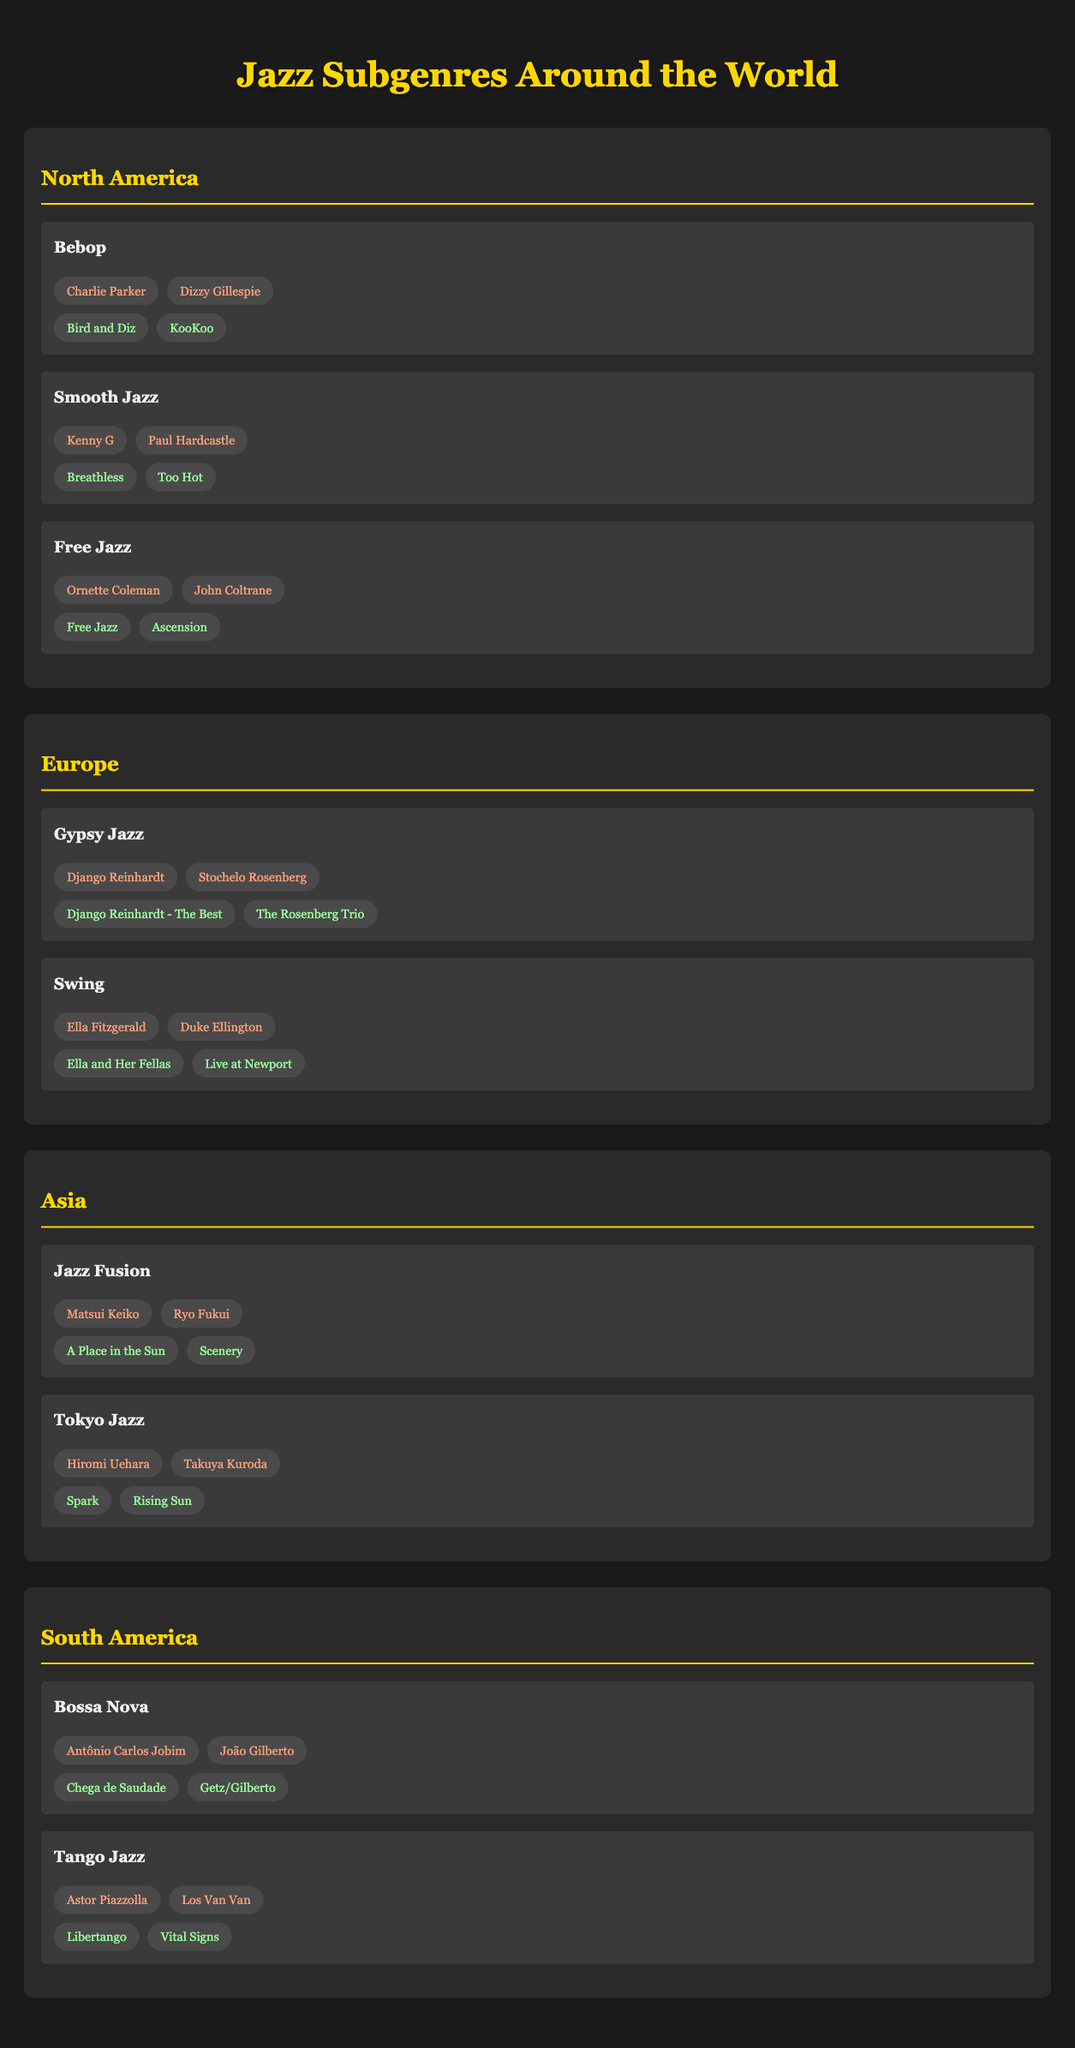What are the notable albums for the Bebop subgenre? The table specifies the notable albums under the Bebop subgenre listed in North America. They are "Bird and Diz" and "KooKoo."
Answer: Bird and Diz, KooKoo Which region is associated with Gypsy Jazz? According to the table, Gypsy Jazz is included in the Europe section, indicating that it is primarily associated with that region.
Answer: Europe Are there any South American subgenres featuring João Gilberto? The table shows that Bossa Nova, which features João Gilberto, is listed under the South America section. Therefore, the answer is yes.
Answer: Yes How many notable albums are listed for the Tango Jazz subgenre? The table lists two notable albums for Tango Jazz: "Libertango" and "Vital Signs." Therefore, the count is two.
Answer: 2 Which artists are known for Smooth Jazz? In the North America section, the artists listed under Smooth Jazz are Kenny G and Paul Hardcastle.
Answer: Kenny G, Paul Hardcastle Which subgenres have notable albums related to John Coltrane? John Coltrane is associated with the Free Jazz subgenre in North America, and the notable albums listed for it are "Free Jazz" and "Ascension."
Answer: Free Jazz Is Ella Fitzgerald an artist featured in the Tokyo Jazz subgenre? Checking the artists listed under Tokyo Jazz, they are Hiromi Uehara and Takuya Kuroda. Ella Fitzgerald is not mentioned there, so the answer is no.
Answer: No What is the sum of notable albums listed for South America? There are two subgenres in South America, each with two notable albums—Bossa Nova and Tango Jazz. Therefore, the total count is 2 (Bossa Nova) + 2 (Tango Jazz) = 4.
Answer: 4 Which jazz subgenre from South America features Antônio Carlos Jobim? The table indicates that Bossa Nova features Antônio Carlos Jobim, making it the subgenre in question.
Answer: Bossa Nova 